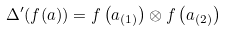Convert formula to latex. <formula><loc_0><loc_0><loc_500><loc_500>\Delta ^ { \prime } ( f ( a ) ) = f \left ( a _ { ( 1 ) } \right ) \otimes f \left ( a _ { ( 2 ) } \right )</formula> 